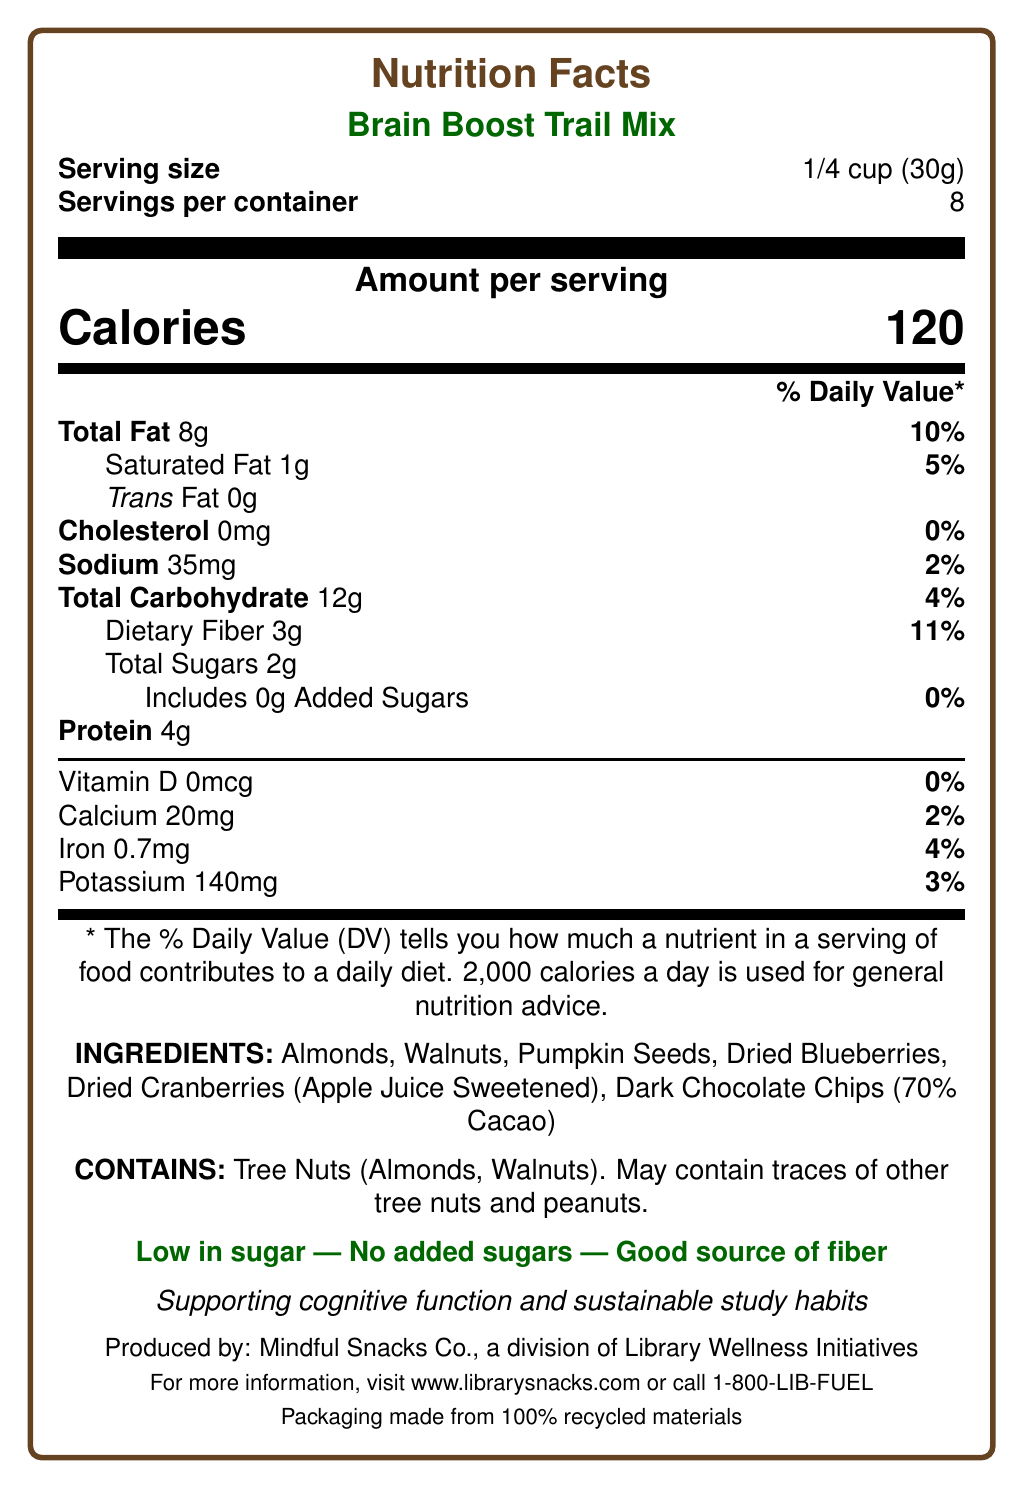what is the serving size of the Brain Boost Trail Mix? The document specifies that the serving size is 1/4 cup (30g).
Answer: 1/4 cup (30g) how many calories are there per serving? The document lists 120 calories per serving.
Answer: 120 which ingredient is sweetened with apple juice? The document indicates "Dried Cranberries (Apple Juice Sweetened)" in the ingredients list.
Answer: Dried Cranberries what is the total fat content per serving? The document states that the total fat content per serving is 8g.
Answer: 8g how much iron does one serving provide? One serving provides 0.7mg of iron, as indicated in the document.
Answer: 0.7mg Are there any added sugars in the mix? (Yes/No) The document states that the mix includes 0g Added Sugars.
Answer: No what are the health benefits claimed for this product? The marketing claims section of the document lists these health benefits.
Answer: Low in sugar, No added sugars, Good source of fiber, Rich in heart-healthy fats, Contains antioxidants what is the main purpose of the Brain Boost Trail Mix according to the brand statement? The brand statement specifies that the product is aimed at supporting cognitive function and sustainable study habits.
Answer: Supporting cognitive function and sustainable study habits how many servings are in each container? The document specifies that there are 8 servings per container.
Answer: 8 which of the following nutrients has the highest % Daily Value per serving? A. Sodium B. Dietary Fiber C. Protein D. Total Fat Total Fat has a % Daily Value of 10%, which is higher than sodium (2%), dietary fiber (11%), and protein (not listed with % Daily Value).
Answer: D. Total Fat where is the trail mix produced? The document states that the product is produced by Mindful Snacks Co., a division of Library Wellness Initiatives.
Answer: Mindful Snacks Co., a division of Library Wellness Initiatives For more information about the product, which website can be visited? The document provides this website for more information about the product.
Answer: www.librarysnacks.com What is the packaging of the Brain Boost Trail Mix made from? The sustainability information section mentions that the packaging is made from 100% recycled materials.
Answer: 100% recycled materials which of the following allergens does the product contain? A. Peanuts B. Dairy C. Tree Nuts D. Soy The allergen statement specifies that the product contains tree nuts (Almonds, Walnuts) and may contain traces of other tree nuts and peanuts.
Answer: C. Tree Nuts does the product contain any cholesterol? (Yes/No) The document indicates that the cholesterol content per serving is 0mg.
Answer: No what is the primary source of antioxidants in this product? The marketing claims highlight that the product contains antioxidants from dark chocolate and berries.
Answer: Dark Chocolate and berries what is the sodium content of each serving? The document specifies that there are 35mg of sodium per serving.
Answer: 35mg Are the ingredients used in the Brain Boost Trail Mix organic? The document does not provide information on whether the ingredients are organic.
Answer: Not enough information Summarize the main features and nutritional highlights of the Brain Boost Trail Mix. This summary collates the main nutritional and marketing information provided in the document, with emphasis on its health benefits and core ingredients.
Answer: The Brain Boost Trail Mix is a healthy snack option designed to support cognitive function and sustainable study habits. Each 1/4 cup serving contains 120 calories, 8g of total fat, 3g of dietary fiber, and 2g of total sugars with no added sugars. It is low in sugar, a good source of fiber, and contains heart-healthy fats and antioxidants from dark chocolate and berries. The mix consists of almonds, walnuts, pumpkin seeds, dried blueberries, dried cranberries sweetened with apple juice, and dark chocolate chips. The packaging is made from 100% recycled materials, and the product is produced by Mindful Snacks Co., a division of Library Wellness Initiatives. 